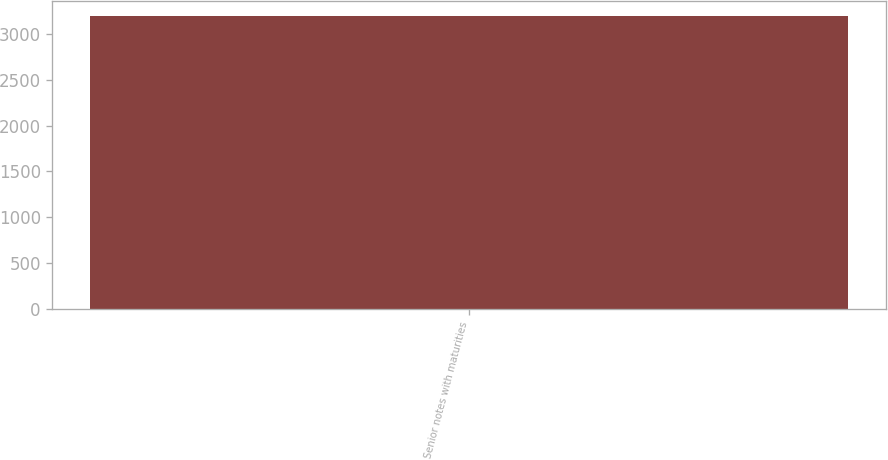Convert chart. <chart><loc_0><loc_0><loc_500><loc_500><bar_chart><fcel>Senior notes with maturities<nl><fcel>3200<nl></chart> 